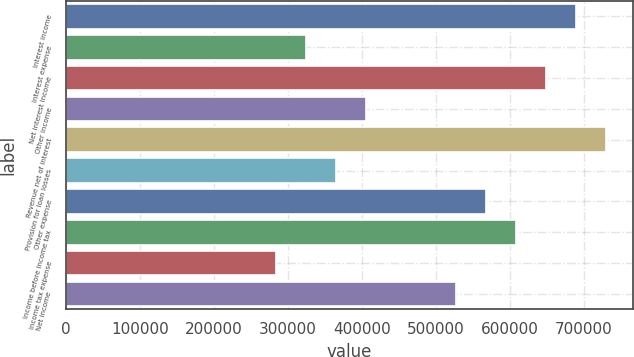<chart> <loc_0><loc_0><loc_500><loc_500><bar_chart><fcel>Interest income<fcel>Interest expense<fcel>Net interest income<fcel>Other income<fcel>Revenue net of interest<fcel>Provision for loan losses<fcel>Other expense<fcel>Income before income tax<fcel>Income tax expense<fcel>Net income<nl><fcel>689667<fcel>324550<fcel>649098<fcel>405687<fcel>730236<fcel>365118<fcel>567961<fcel>608530<fcel>283981<fcel>527393<nl></chart> 